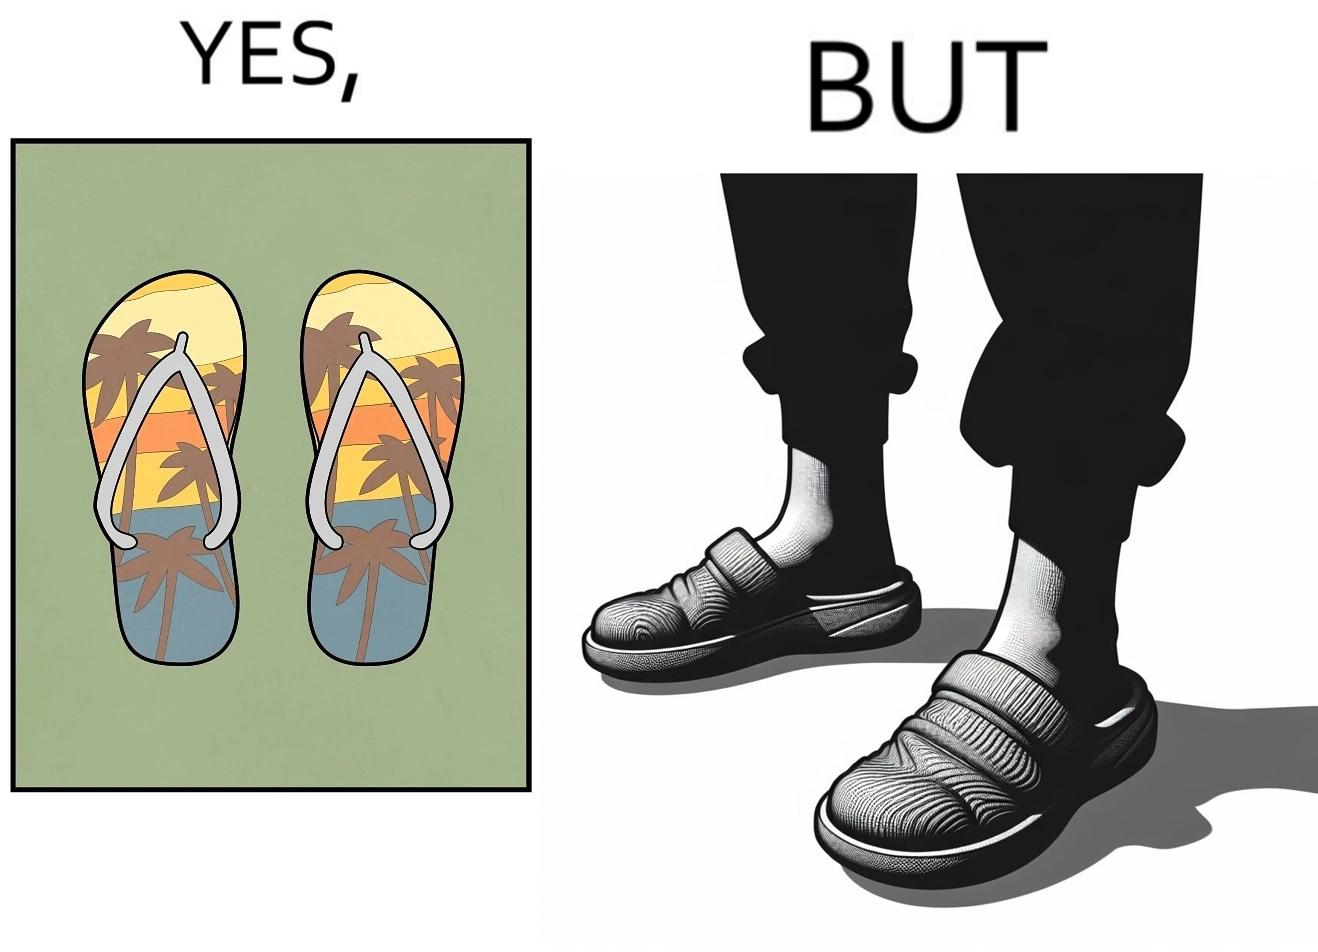Is this a satirical image? Yes, this image is satirical. 